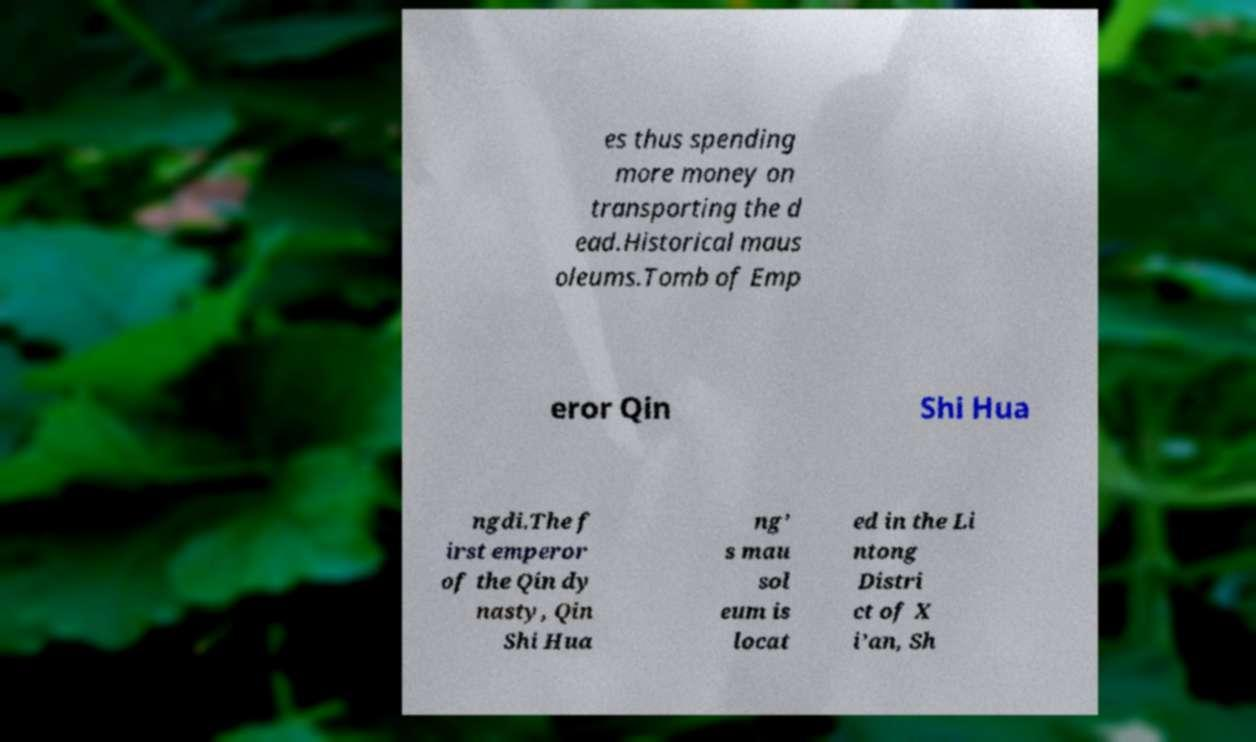There's text embedded in this image that I need extracted. Can you transcribe it verbatim? es thus spending more money on transporting the d ead.Historical maus oleums.Tomb of Emp eror Qin Shi Hua ngdi.The f irst emperor of the Qin dy nasty, Qin Shi Hua ng’ s mau sol eum is locat ed in the Li ntong Distri ct of X i’an, Sh 